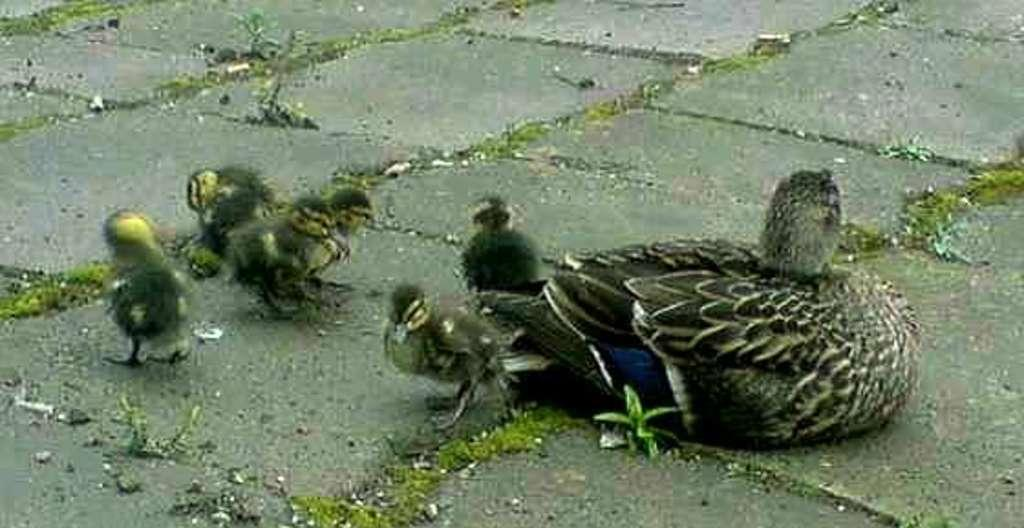What type of animals can be seen on the floor in the image? There are birds on the floor in the image. Can you describe the position of the birds in the image? The birds are on the floor in the image. What might the birds be doing in the image? The image does not provide enough information to determine what the birds are doing. What advice is the arm giving to the animal in the image? There is no arm or animal present in the image; it only features birds on the floor. 